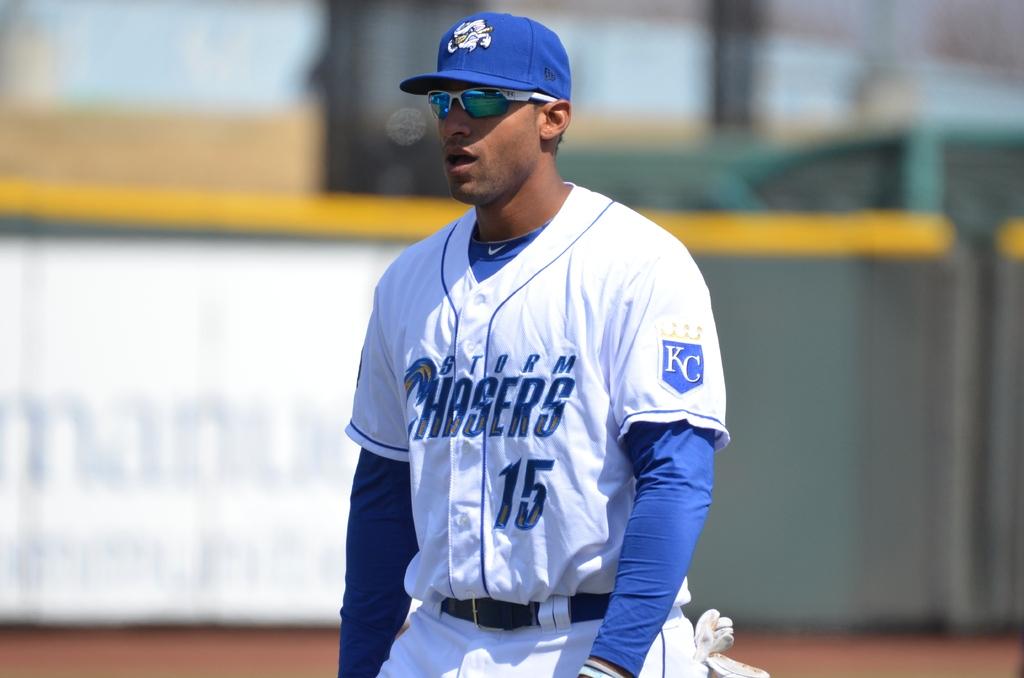What is the number on the players jersey?
Provide a short and direct response. 15. What team does #15 play for?
Provide a short and direct response. Storm chasers. 